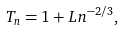Convert formula to latex. <formula><loc_0><loc_0><loc_500><loc_500>T _ { n } = 1 + L n ^ { - 2 / 3 } ,</formula> 